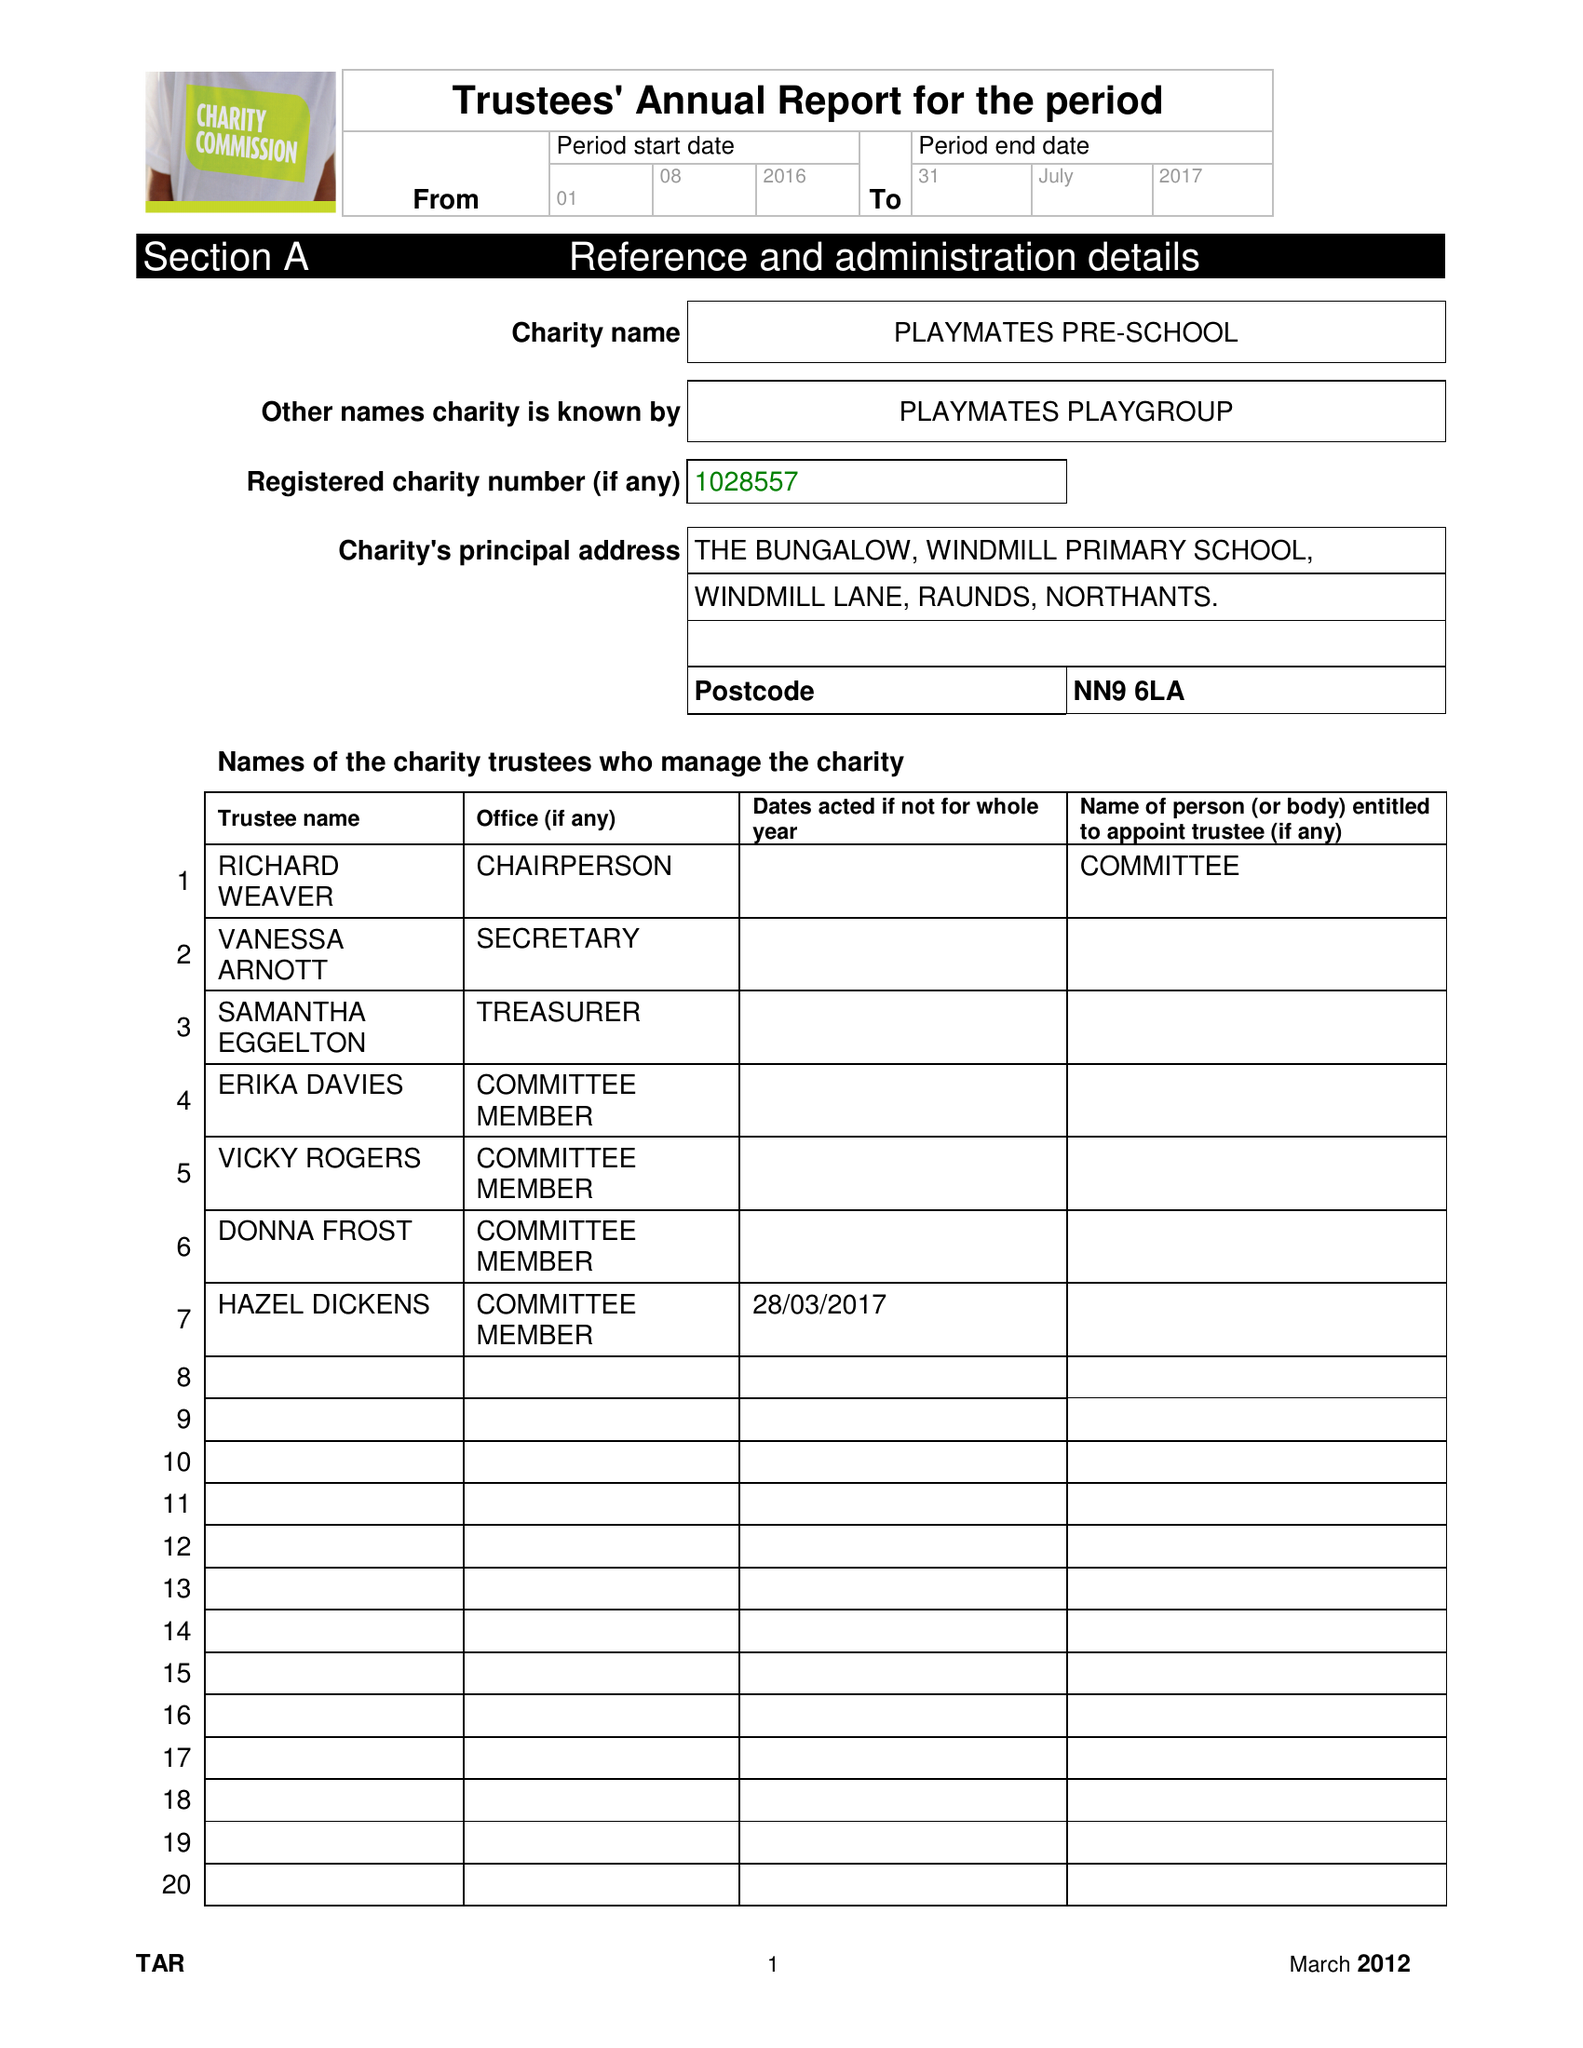What is the value for the charity_name?
Answer the question using a single word or phrase. Playmates Playgroup 